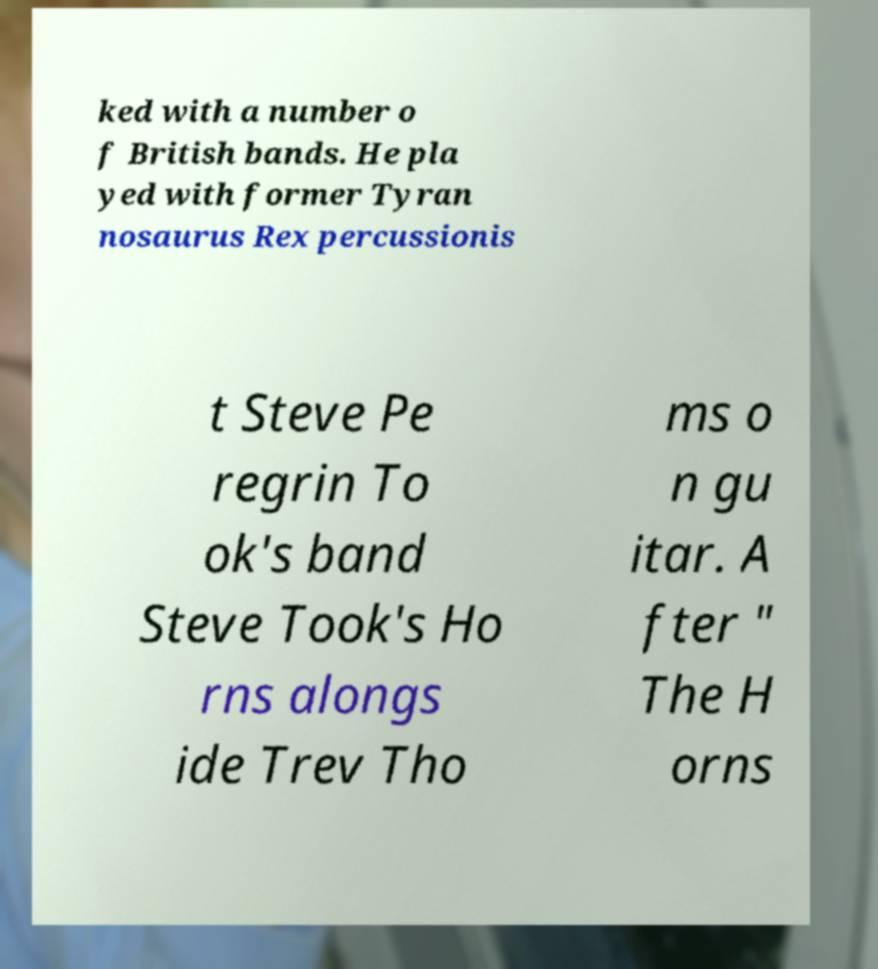For documentation purposes, I need the text within this image transcribed. Could you provide that? ked with a number o f British bands. He pla yed with former Tyran nosaurus Rex percussionis t Steve Pe regrin To ok's band Steve Took's Ho rns alongs ide Trev Tho ms o n gu itar. A fter " The H orns 